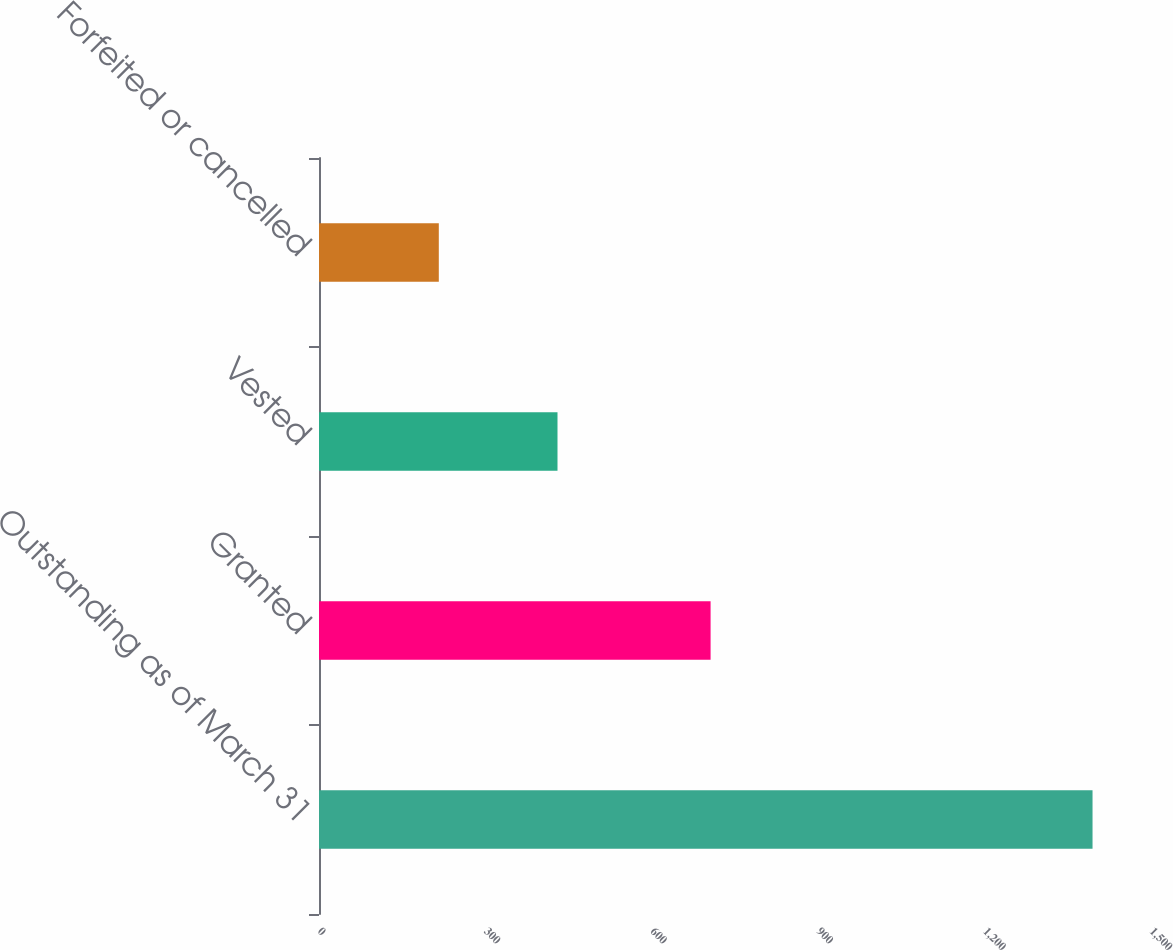Convert chart to OTSL. <chart><loc_0><loc_0><loc_500><loc_500><bar_chart><fcel>Outstanding as of March 31<fcel>Granted<fcel>Vested<fcel>Forfeited or cancelled<nl><fcel>1394.6<fcel>706<fcel>430<fcel>216<nl></chart> 